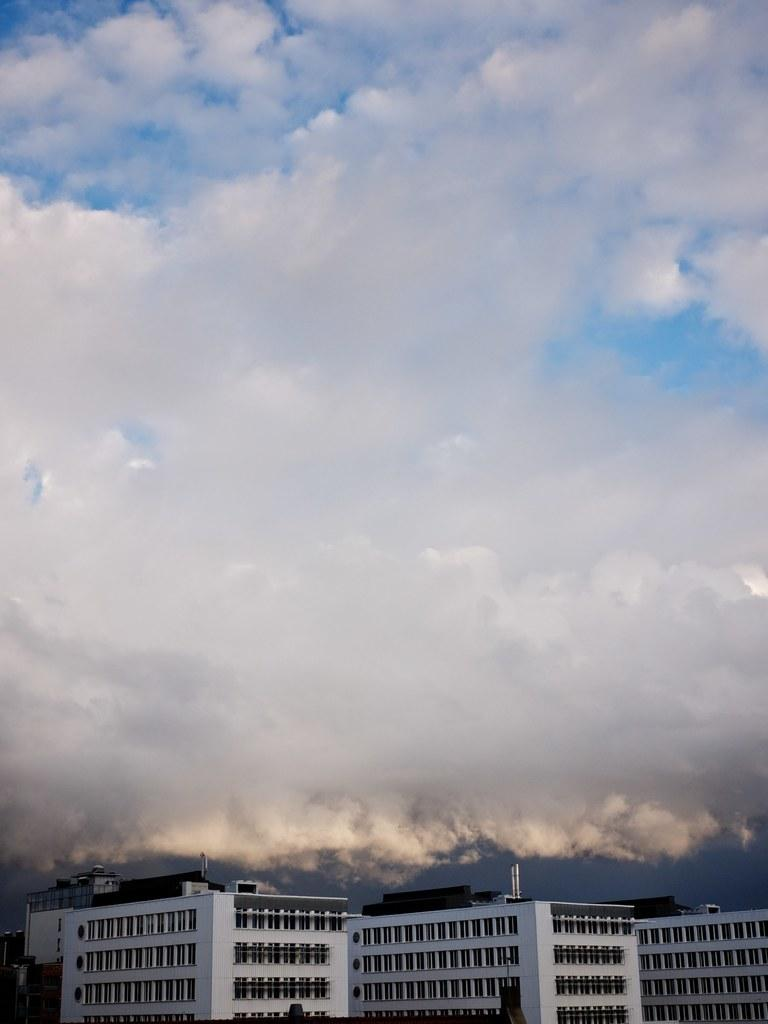What type of structures are present in the image? There are buildings in the image. What feature can be seen on the buildings? The buildings have windows. What can be seen in the sky at the top of the image? There are clouds visible in the sky. Can you tell me how many farm animals are grazing in the image? There are no farm animals present in the image; it features buildings and clouds. What type of wave can be seen in the image? There is no wave present in the image; it features buildings, windows, and clouds. 